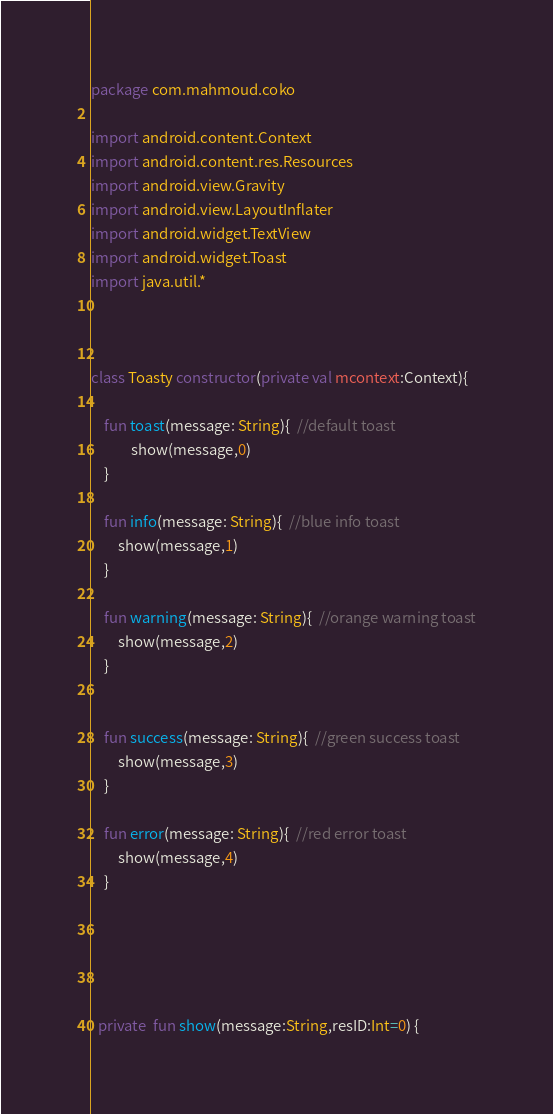Convert code to text. <code><loc_0><loc_0><loc_500><loc_500><_Kotlin_>package com.mahmoud.coko

import android.content.Context
import android.content.res.Resources
import android.view.Gravity
import android.view.LayoutInflater
import android.widget.TextView
import android.widget.Toast
import java.util.*



class Toasty constructor(private val mcontext:Context){

    fun toast(message: String){  //default toast
            show(message,0)
    }

    fun info(message: String){  //blue info toast
        show(message,1)
    }

    fun warning(message: String){  //orange warning toast
        show(message,2)
    }


    fun success(message: String){  //green success toast
        show(message,3)
    }

    fun error(message: String){  //red error toast
        show(message,4)
    }





  private  fun show(message:String,resID:Int=0) {</code> 